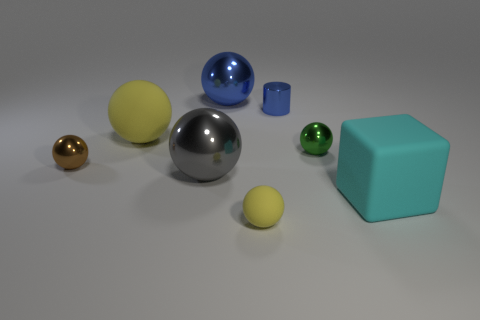Subtract all green metal spheres. How many spheres are left? 5 Add 1 large spheres. How many objects exist? 9 Subtract all blocks. How many objects are left? 7 Subtract all gray cubes. How many purple spheres are left? 0 Subtract all small red matte cylinders. Subtract all brown objects. How many objects are left? 7 Add 3 metallic objects. How many metallic objects are left? 8 Add 2 tiny green things. How many tiny green things exist? 3 Subtract all green balls. How many balls are left? 5 Subtract 0 green cylinders. How many objects are left? 8 Subtract 1 cubes. How many cubes are left? 0 